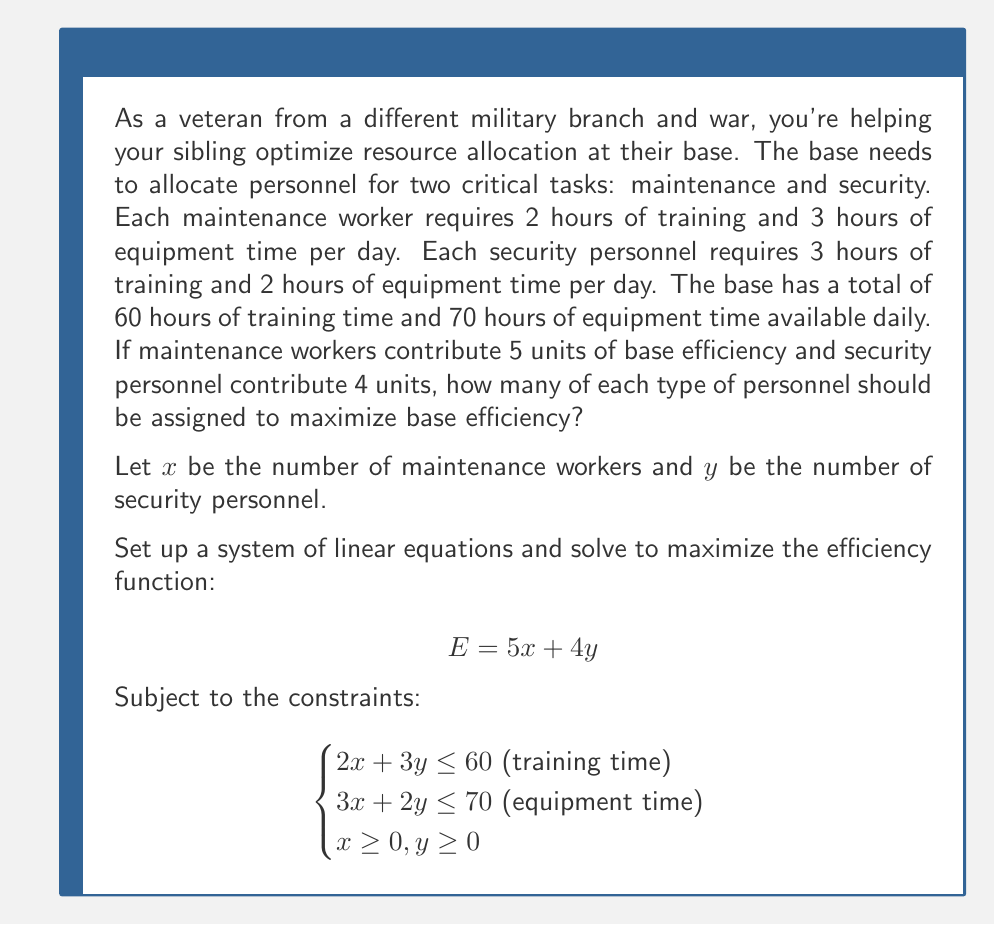Can you solve this math problem? To solve this problem, we'll use the following steps:

1) First, we'll graph the constraints to visualize the feasible region.

2) Then, we'll find the corner points of the feasible region.

3) Finally, we'll evaluate the efficiency function at each corner point to find the maximum.

Step 1: Graphing the constraints

We have two main constraints:
$$2x + 3y = 60$$ (training time)
$$3x + 2y = 70$$ (equipment time)

[asy]
size(200,200);
import graph;

xaxis("x",0,30);
yaxis("y",0,30);

draw((0,20)--(30,0),blue);
draw((0,35)--(23.33,0),red);

label("2x + 3y = 60",(-1,25),blue);
label("3x + 2y = 70",(25,5),red);

fill((0,20)--(0,23.33)--(10,20)--(23.33,0)--(20,0)--cycle,palegreen+opacity(0.2));
[/asy]

The shaded region represents the feasible region.

Step 2: Finding corner points

The corner points are:
- (0, 20) [where the training time line intersects y-axis]
- (0, 23.33) [where the equipment time line intersects y-axis]
- (23.33, 0) [where the equipment time line intersects x-axis]
- (30, 0) [where the training time line intersects x-axis]
- The intersection point of the two lines

To find the intersection point, we solve:

$$\begin{cases}
2x + 3y = 60 \\
3x + 2y = 70
\end{cases}$$

Multiplying the first equation by 3 and the second by -2:

$$\begin{cases}
6x + 9y = 180 \\
-6x - 4y = -140
\end{cases}$$

Adding these equations:
$$5y = 40$$
$$y = 8$$

Substituting back:
$$2x + 3(8) = 60$$
$$2x = 36$$
$$x = 18$$

So the intersection point is (18, 8).

Step 3: Evaluating the efficiency function

Now we evaluate $E = 5x + 4y$ at each corner point:

- E(0, 20) = 5(0) + 4(20) = 80
- E(0, 23.33) = 5(0) + 4(23.33) = 93.32
- E(23.33, 0) = 5(23.33) + 4(0) = 116.65
- E(30, 0) = 5(30) + 4(0) = 150
- E(18, 8) = 5(18) + 4(8) = 122

The maximum value is 150, occurring at the point (30, 0).
Answer: To maximize base efficiency, assign 30 maintenance workers and 0 security personnel. This will result in a maximum efficiency of 150 units. 